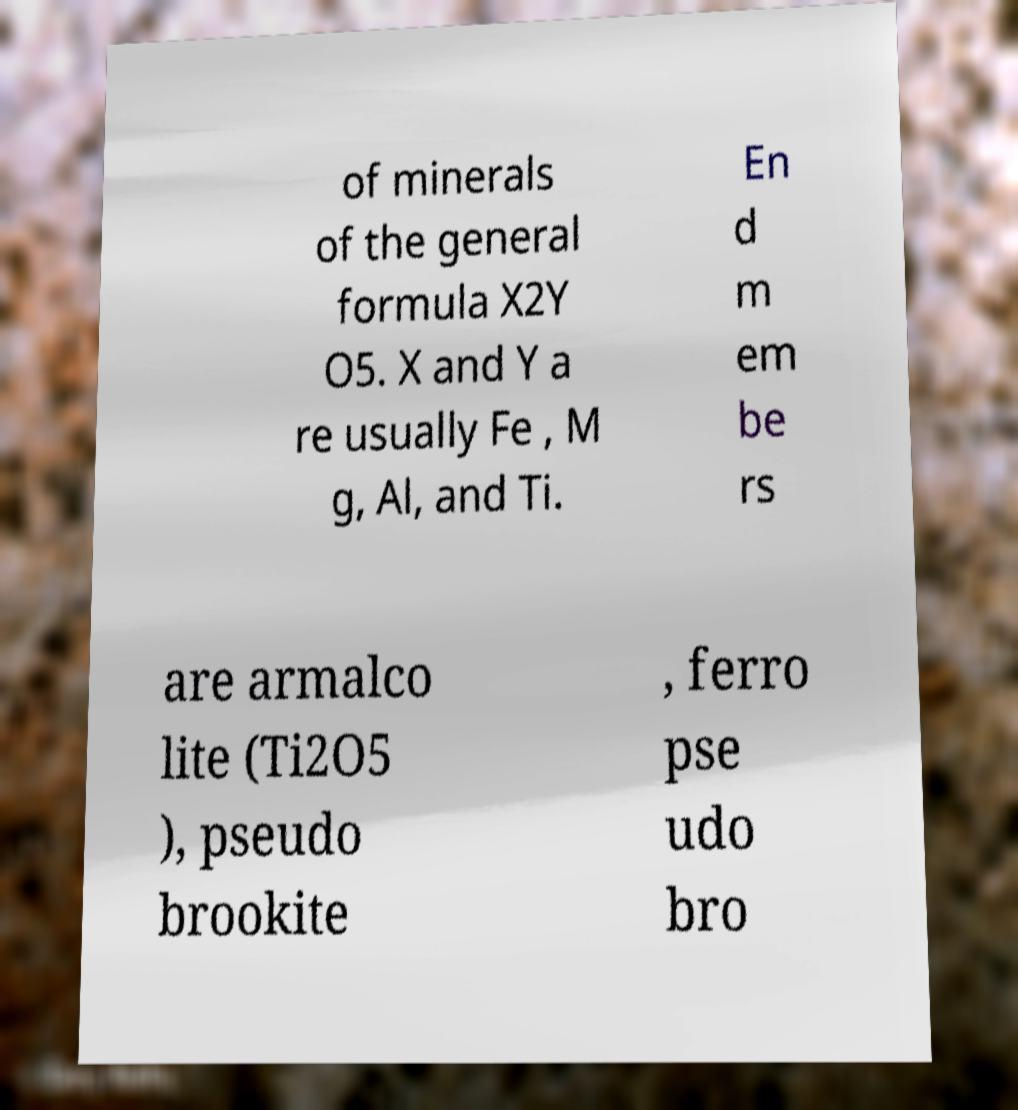What messages or text are displayed in this image? I need them in a readable, typed format. of minerals of the general formula X2Y O5. X and Y a re usually Fe , M g, Al, and Ti. En d m em be rs are armalco lite (Ti2O5 ), pseudo brookite , ferro pse udo bro 